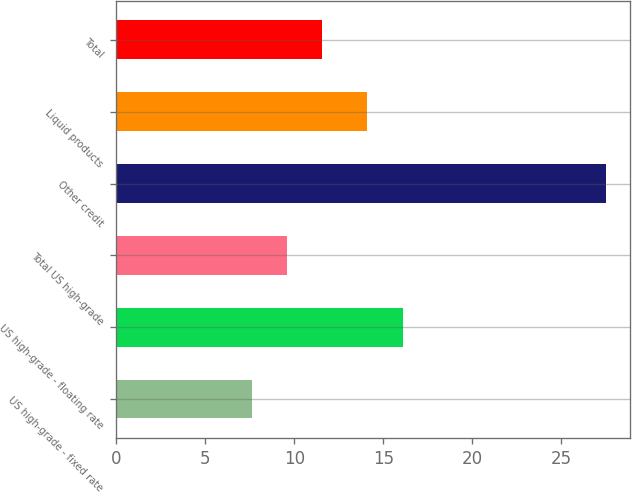<chart> <loc_0><loc_0><loc_500><loc_500><bar_chart><fcel>US high-grade - fixed rate<fcel>US high-grade - floating rate<fcel>Total US high-grade<fcel>Other credit<fcel>Liquid products<fcel>Total<nl><fcel>7.6<fcel>16.09<fcel>9.59<fcel>27.5<fcel>14.1<fcel>11.58<nl></chart> 